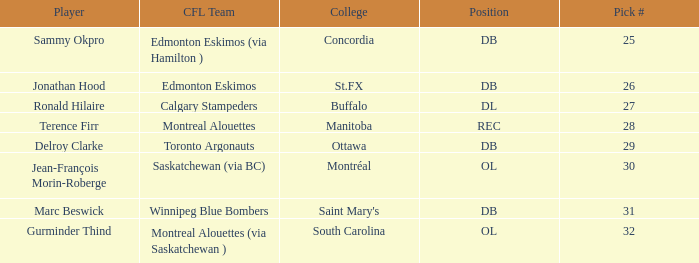In which college can an offensive lineman with a draft pick of less than 32 be found? Montréal. 